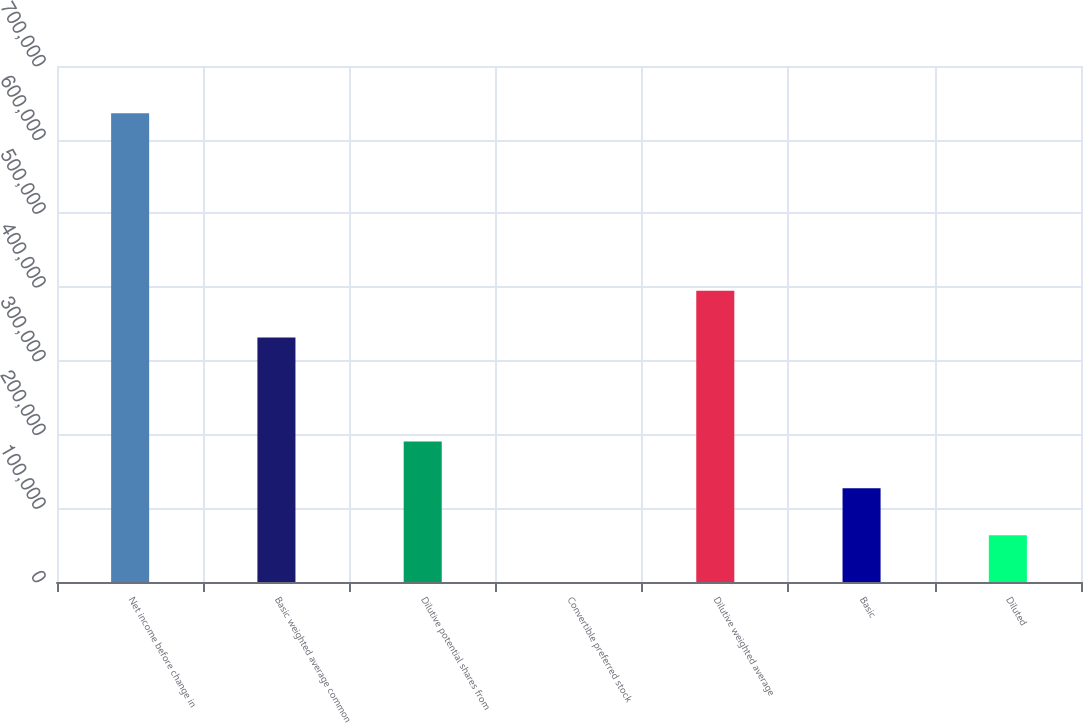<chart> <loc_0><loc_0><loc_500><loc_500><bar_chart><fcel>Net income before change in<fcel>Basic weighted average common<fcel>Dilutive potential shares from<fcel>Convertible preferred stock<fcel>Dilutive weighted average<fcel>Basic<fcel>Diluted<nl><fcel>635857<fcel>331612<fcel>190758<fcel>1<fcel>395198<fcel>127172<fcel>63586.6<nl></chart> 